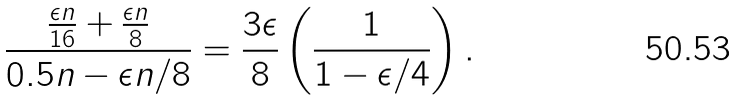Convert formula to latex. <formula><loc_0><loc_0><loc_500><loc_500>\frac { \frac { \epsilon n } { 1 6 } + \frac { \epsilon n } { 8 } } { 0 . 5 n - \epsilon n / 8 } = \frac { 3 \epsilon } { 8 } \left ( \frac { 1 } { 1 - \epsilon / 4 } \right ) .</formula> 